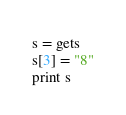Convert code to text. <code><loc_0><loc_0><loc_500><loc_500><_Ruby_>s = gets
s[3] = "8"
print s
</code> 